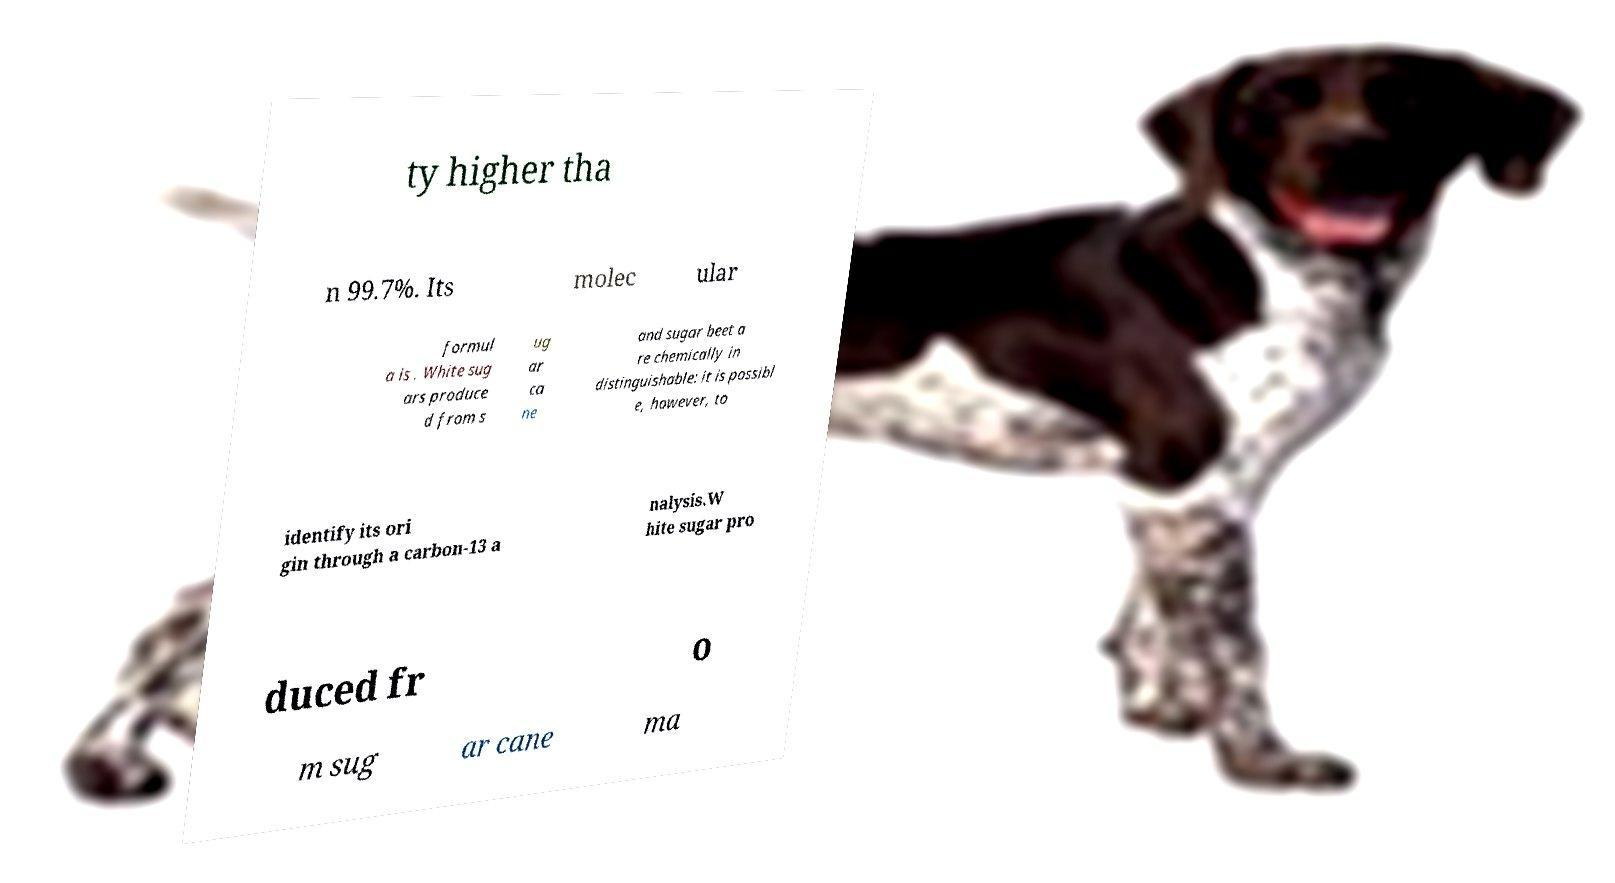What messages or text are displayed in this image? I need them in a readable, typed format. ty higher tha n 99.7%. Its molec ular formul a is . White sug ars produce d from s ug ar ca ne and sugar beet a re chemically in distinguishable: it is possibl e, however, to identify its ori gin through a carbon-13 a nalysis.W hite sugar pro duced fr o m sug ar cane ma 